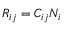<formula> <loc_0><loc_0><loc_500><loc_500>R _ { i j } = C _ { i j } N _ { i }</formula> 